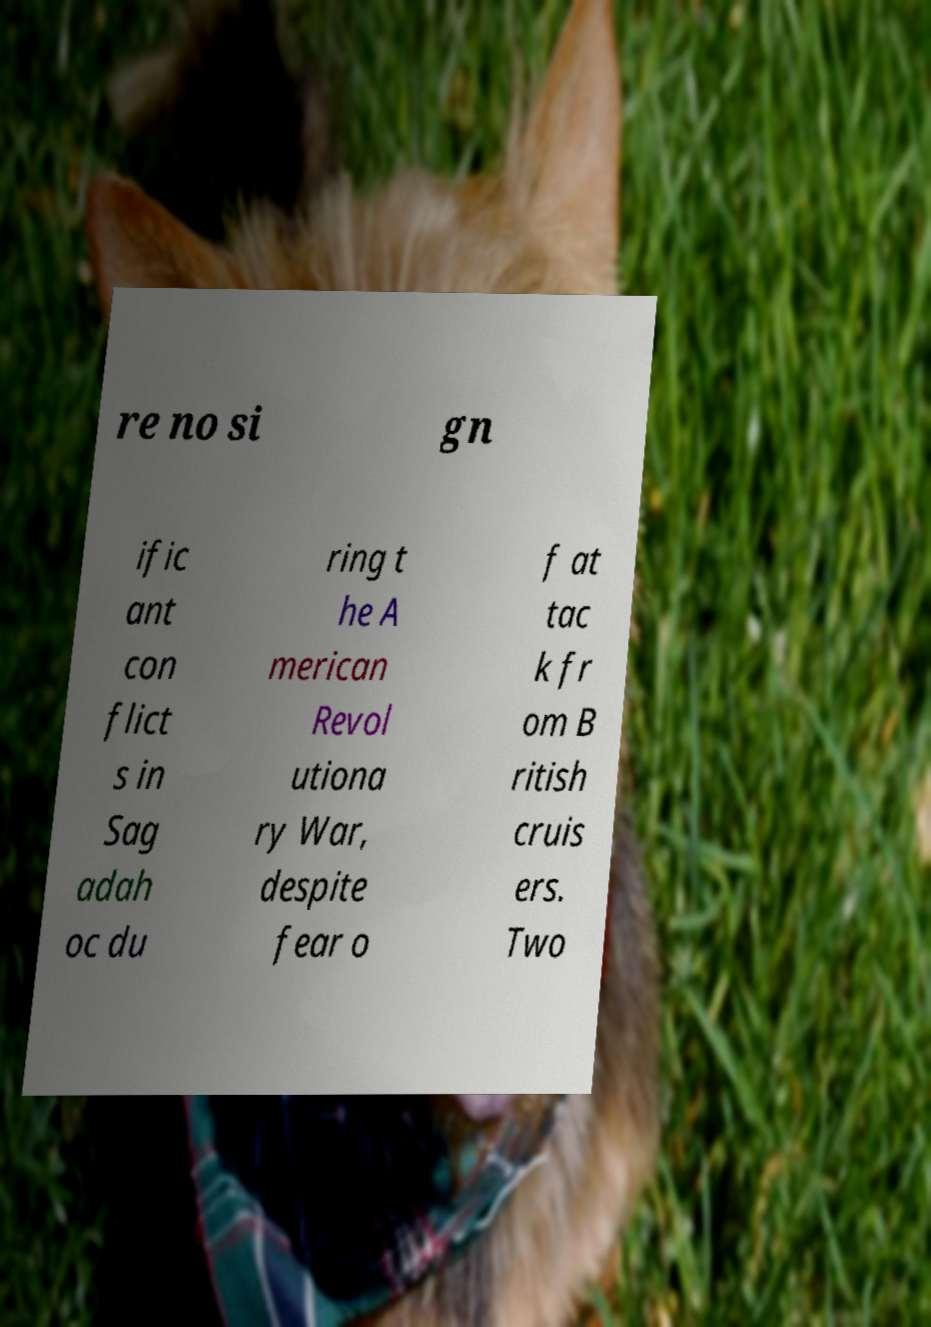I need the written content from this picture converted into text. Can you do that? re no si gn ific ant con flict s in Sag adah oc du ring t he A merican Revol utiona ry War, despite fear o f at tac k fr om B ritish cruis ers. Two 